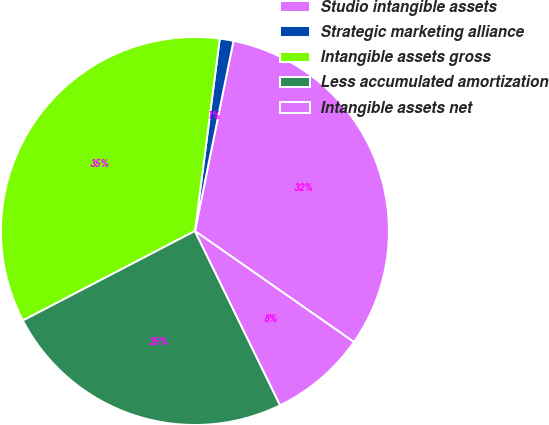Convert chart to OTSL. <chart><loc_0><loc_0><loc_500><loc_500><pie_chart><fcel>Studio intangible assets<fcel>Strategic marketing alliance<fcel>Intangible assets gross<fcel>Less accumulated amortization<fcel>Intangible assets net<nl><fcel>31.52%<fcel>1.14%<fcel>34.68%<fcel>24.6%<fcel>8.06%<nl></chart> 